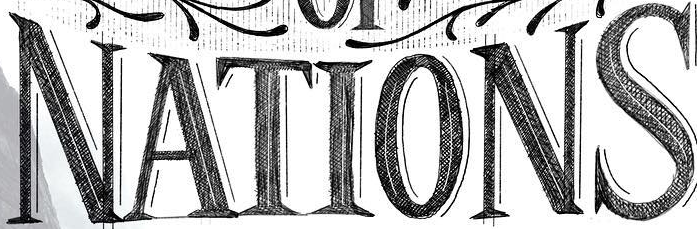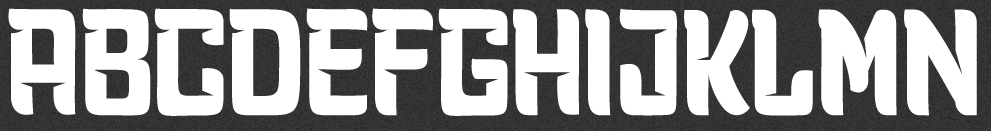What words can you see in these images in sequence, separated by a semicolon? NATIONS; ABCDEFGHIJKLMN 